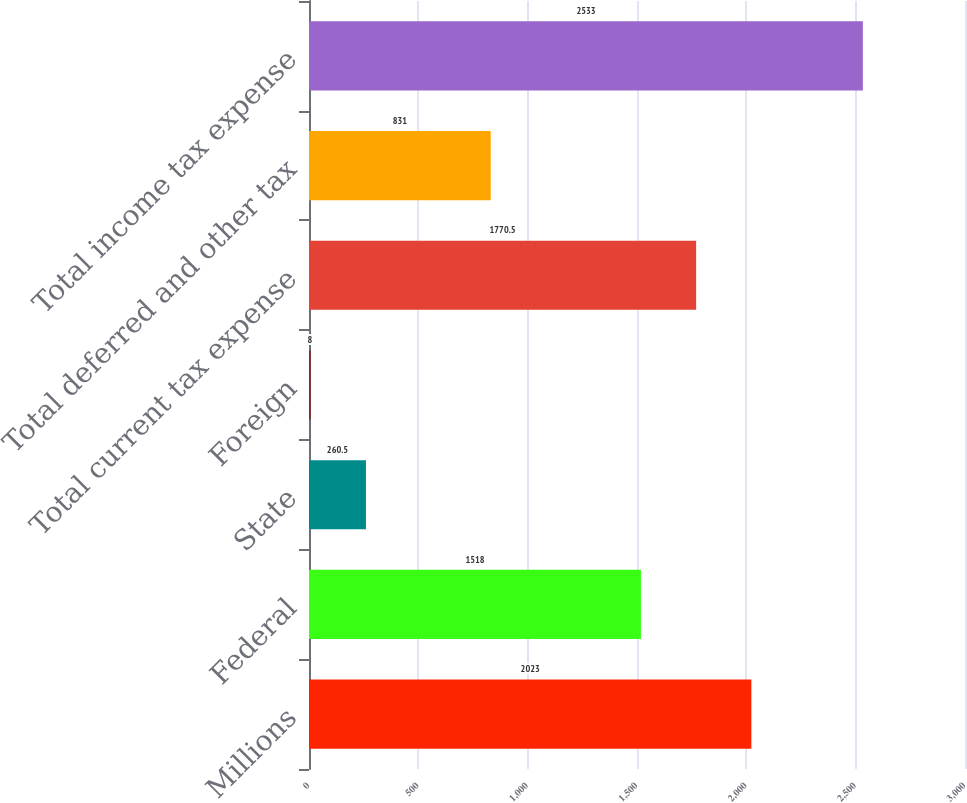Convert chart. <chart><loc_0><loc_0><loc_500><loc_500><bar_chart><fcel>Millions<fcel>Federal<fcel>State<fcel>Foreign<fcel>Total current tax expense<fcel>Total deferred and other tax<fcel>Total income tax expense<nl><fcel>2023<fcel>1518<fcel>260.5<fcel>8<fcel>1770.5<fcel>831<fcel>2533<nl></chart> 